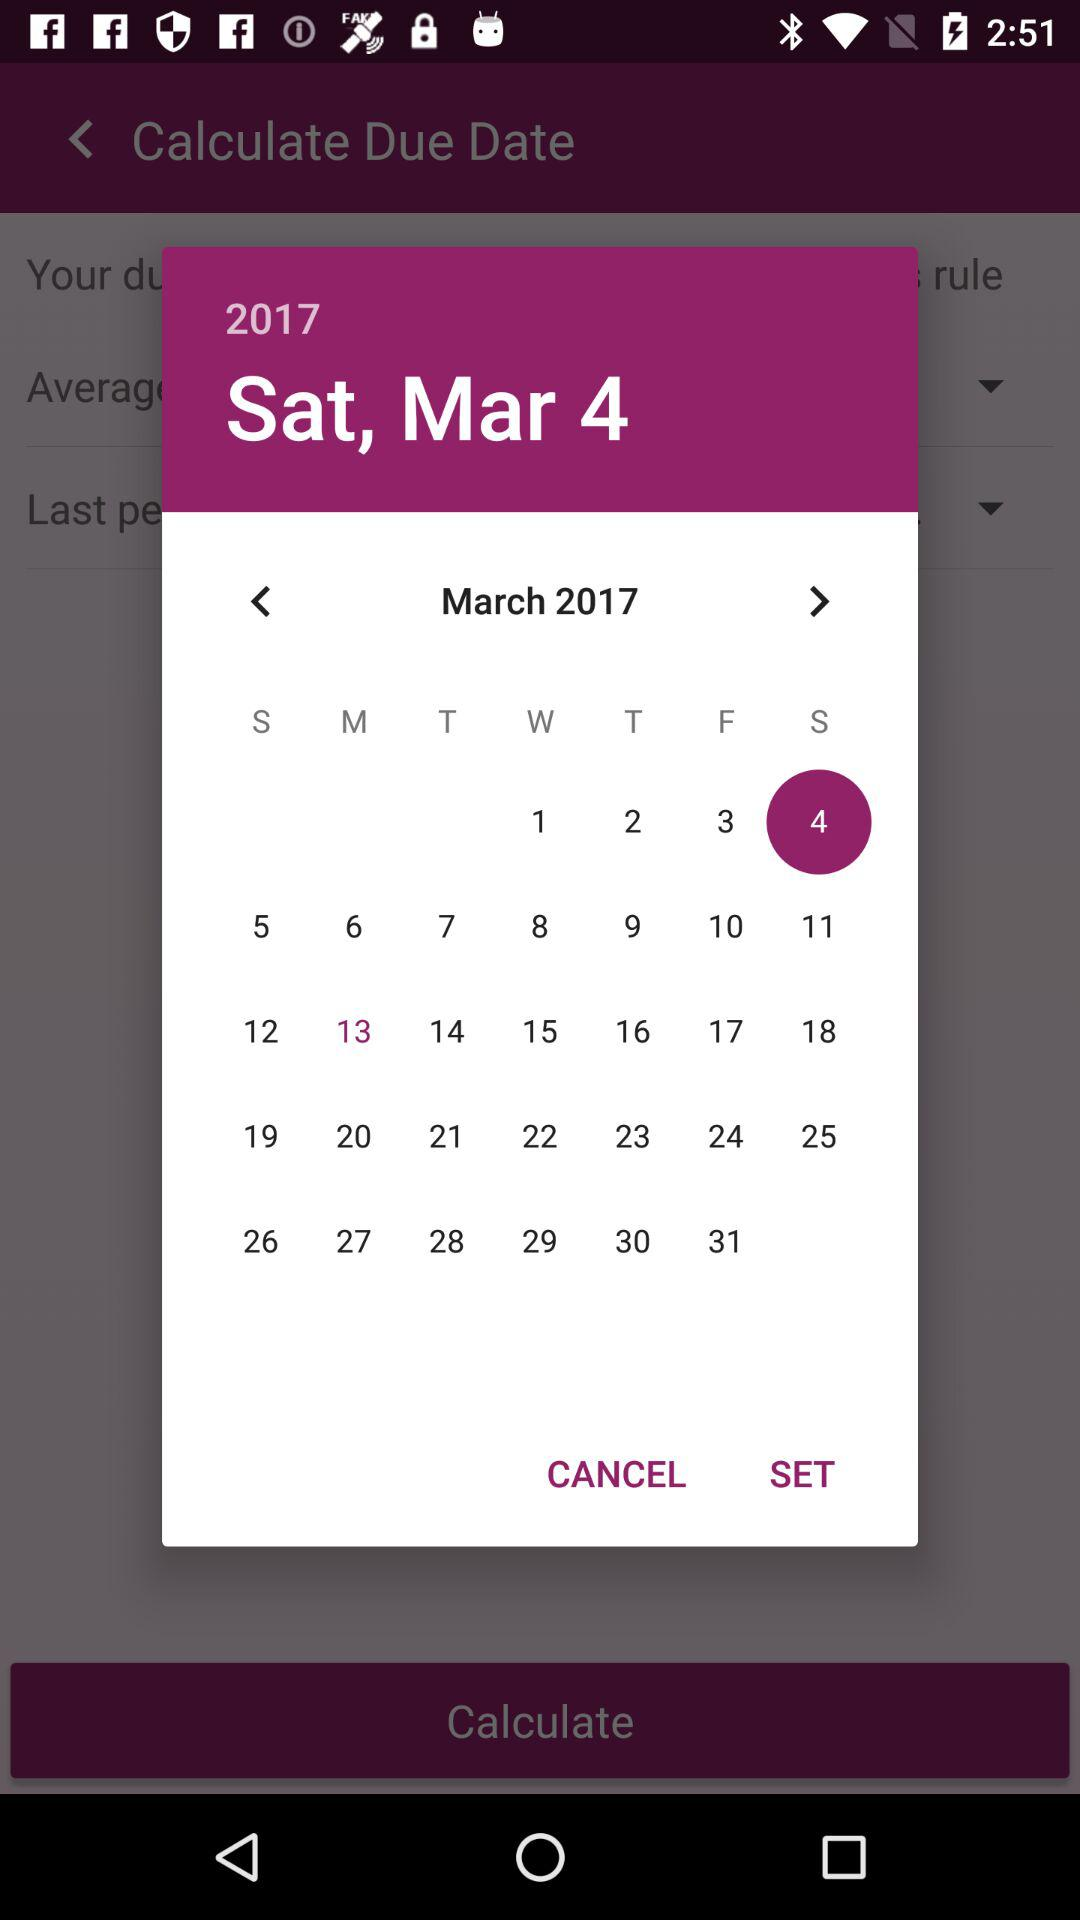Which day falls on the 9th of March? The day falling on the 9th of March is Thursday. 